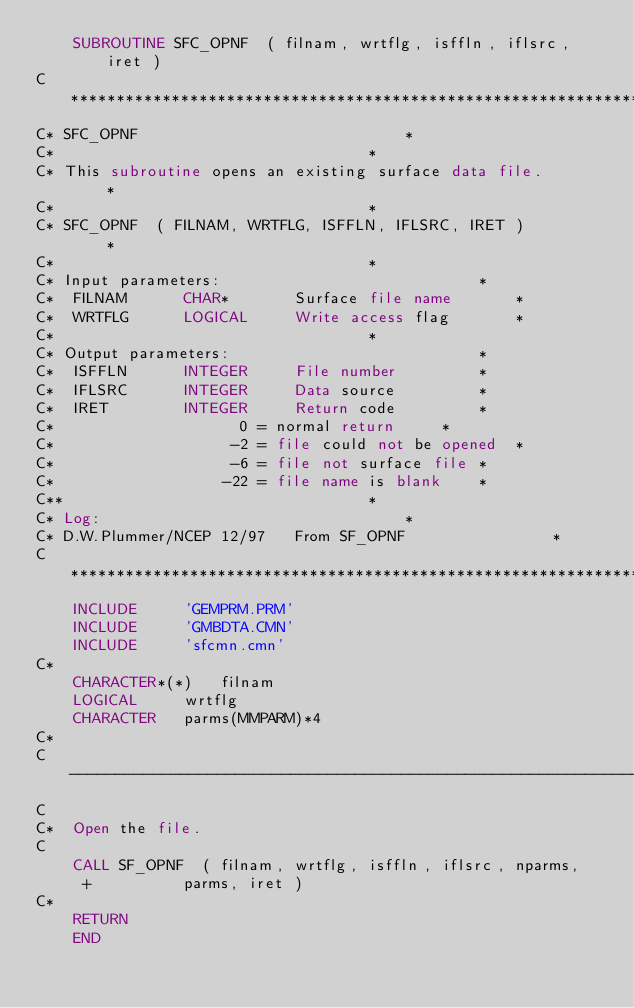Convert code to text. <code><loc_0><loc_0><loc_500><loc_500><_FORTRAN_>	SUBROUTINE SFC_OPNF  ( filnam, wrtflg, isffln, iflsrc, iret )
C************************************************************************
C* SFC_OPNF								*
C*									*
C* This subroutine opens an existing surface data file.			*
C*									*
C* SFC_OPNF  ( FILNAM, WRTFLG, ISFFLN, IFLSRC, IRET )			*
C*									*
C* Input parameters:							*
C*	FILNAM		CHAR*		Surface file name		*
C*	WRTFLG		LOGICAL		Write access flag		*
C*									*
C* Output parameters:							*
C*	ISFFLN		INTEGER		File number			*
C*	IFLSRC		INTEGER		Data source			*
C*	IRET		INTEGER		Return code			*
C*					  0 = normal return		*
C*					 -2 = file could not be opened	*
C*					 -6 = file not surface file	*
C*					-22 = file name is blank	*
C**									*
C* Log: 								*
C* D.W.Plummer/NCEP	12/97	From SF_OPNF				*
C************************************************************************
	INCLUDE		'GEMPRM.PRM'
	INCLUDE		'GMBDTA.CMN'
	INCLUDE		'sfcmn.cmn'
C*
	CHARACTER*(*)	filnam
	LOGICAL		wrtflg
	CHARACTER	parms(MMPARM)*4
C*
C-------------------------------------------------------------------------
C
C*	Open the file.
C
	CALL SF_OPNF  ( filnam, wrtflg, isffln, iflsrc, nparms, 
     +			parms, iret )
C*
	RETURN
	END
</code> 